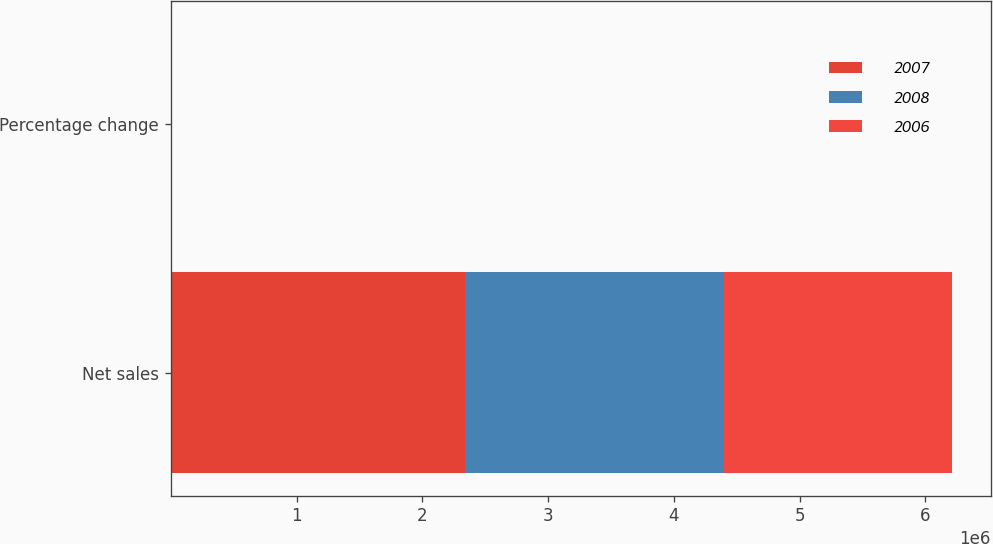<chart> <loc_0><loc_0><loc_500><loc_500><stacked_bar_chart><ecel><fcel>Net sales<fcel>Percentage change<nl><fcel>2007<fcel>2.34042e+06<fcel>13.5<nl><fcel>2008<fcel>2.06182e+06<fcel>14<nl><fcel>2006<fcel>1.80934e+06<fcel>18.8<nl></chart> 